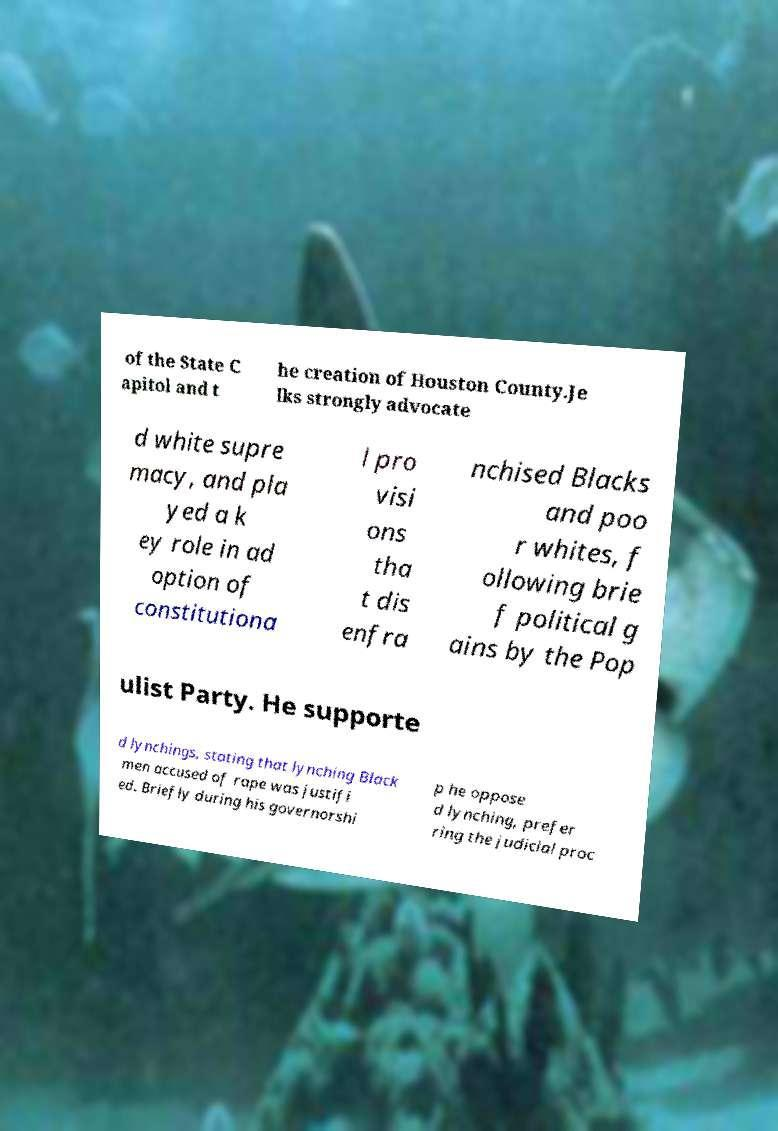Could you assist in decoding the text presented in this image and type it out clearly? of the State C apitol and t he creation of Houston County.Je lks strongly advocate d white supre macy, and pla yed a k ey role in ad option of constitutiona l pro visi ons tha t dis enfra nchised Blacks and poo r whites, f ollowing brie f political g ains by the Pop ulist Party. He supporte d lynchings, stating that lynching Black men accused of rape was justifi ed. Briefly during his governorshi p he oppose d lynching, prefer ring the judicial proc 